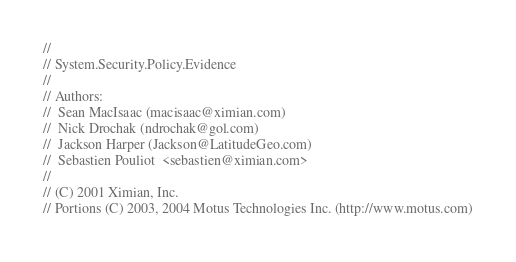<code> <loc_0><loc_0><loc_500><loc_500><_C#_>//
// System.Security.Policy.Evidence
//
// Authors:
//	Sean MacIsaac (macisaac@ximian.com)
//	Nick Drochak (ndrochak@gol.com)
//	Jackson Harper (Jackson@LatitudeGeo.com)
//	Sebastien Pouliot  <sebastien@ximian.com>
//
// (C) 2001 Ximian, Inc.
// Portions (C) 2003, 2004 Motus Technologies Inc. (http://www.motus.com)</code> 